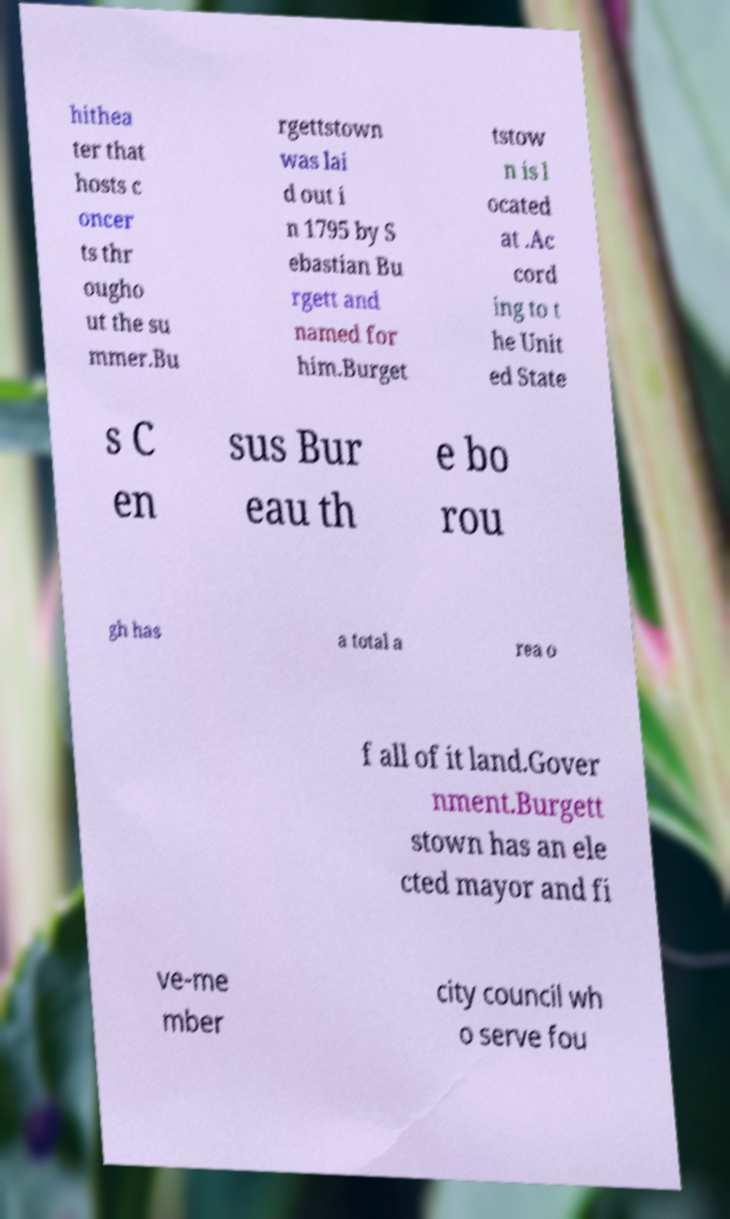Can you accurately transcribe the text from the provided image for me? hithea ter that hosts c oncer ts thr ougho ut the su mmer.Bu rgettstown was lai d out i n 1795 by S ebastian Bu rgett and named for him.Burget tstow n is l ocated at .Ac cord ing to t he Unit ed State s C en sus Bur eau th e bo rou gh has a total a rea o f all of it land.Gover nment.Burgett stown has an ele cted mayor and fi ve-me mber city council wh o serve fou 